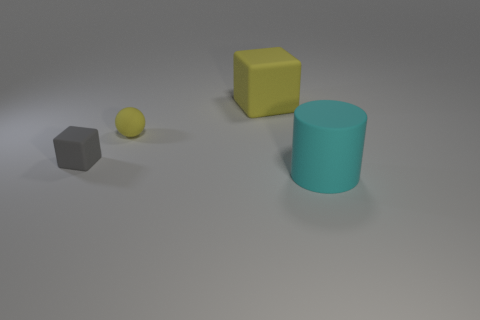How big is the yellow object left of the big cube?
Offer a very short reply. Small. What number of tiny rubber spheres are the same color as the large cylinder?
Provide a succinct answer. 0. How many cubes are tiny rubber objects or tiny blue objects?
Make the answer very short. 1. What is the shape of the rubber object that is both to the right of the tiny matte sphere and in front of the tiny sphere?
Ensure brevity in your answer.  Cylinder. Is there a gray rubber thing of the same size as the gray cube?
Your response must be concise. No. How many things are either large objects on the left side of the cyan matte thing or large yellow objects?
Your answer should be compact. 1. Is the large cyan object made of the same material as the block in front of the large matte block?
Your answer should be compact. Yes. What number of other things are there of the same shape as the tiny yellow thing?
Keep it short and to the point. 0. How many objects are either matte objects to the left of the small yellow matte sphere or rubber objects on the left side of the large cyan matte cylinder?
Your answer should be compact. 3. What number of other objects are the same color as the matte sphere?
Provide a succinct answer. 1. 